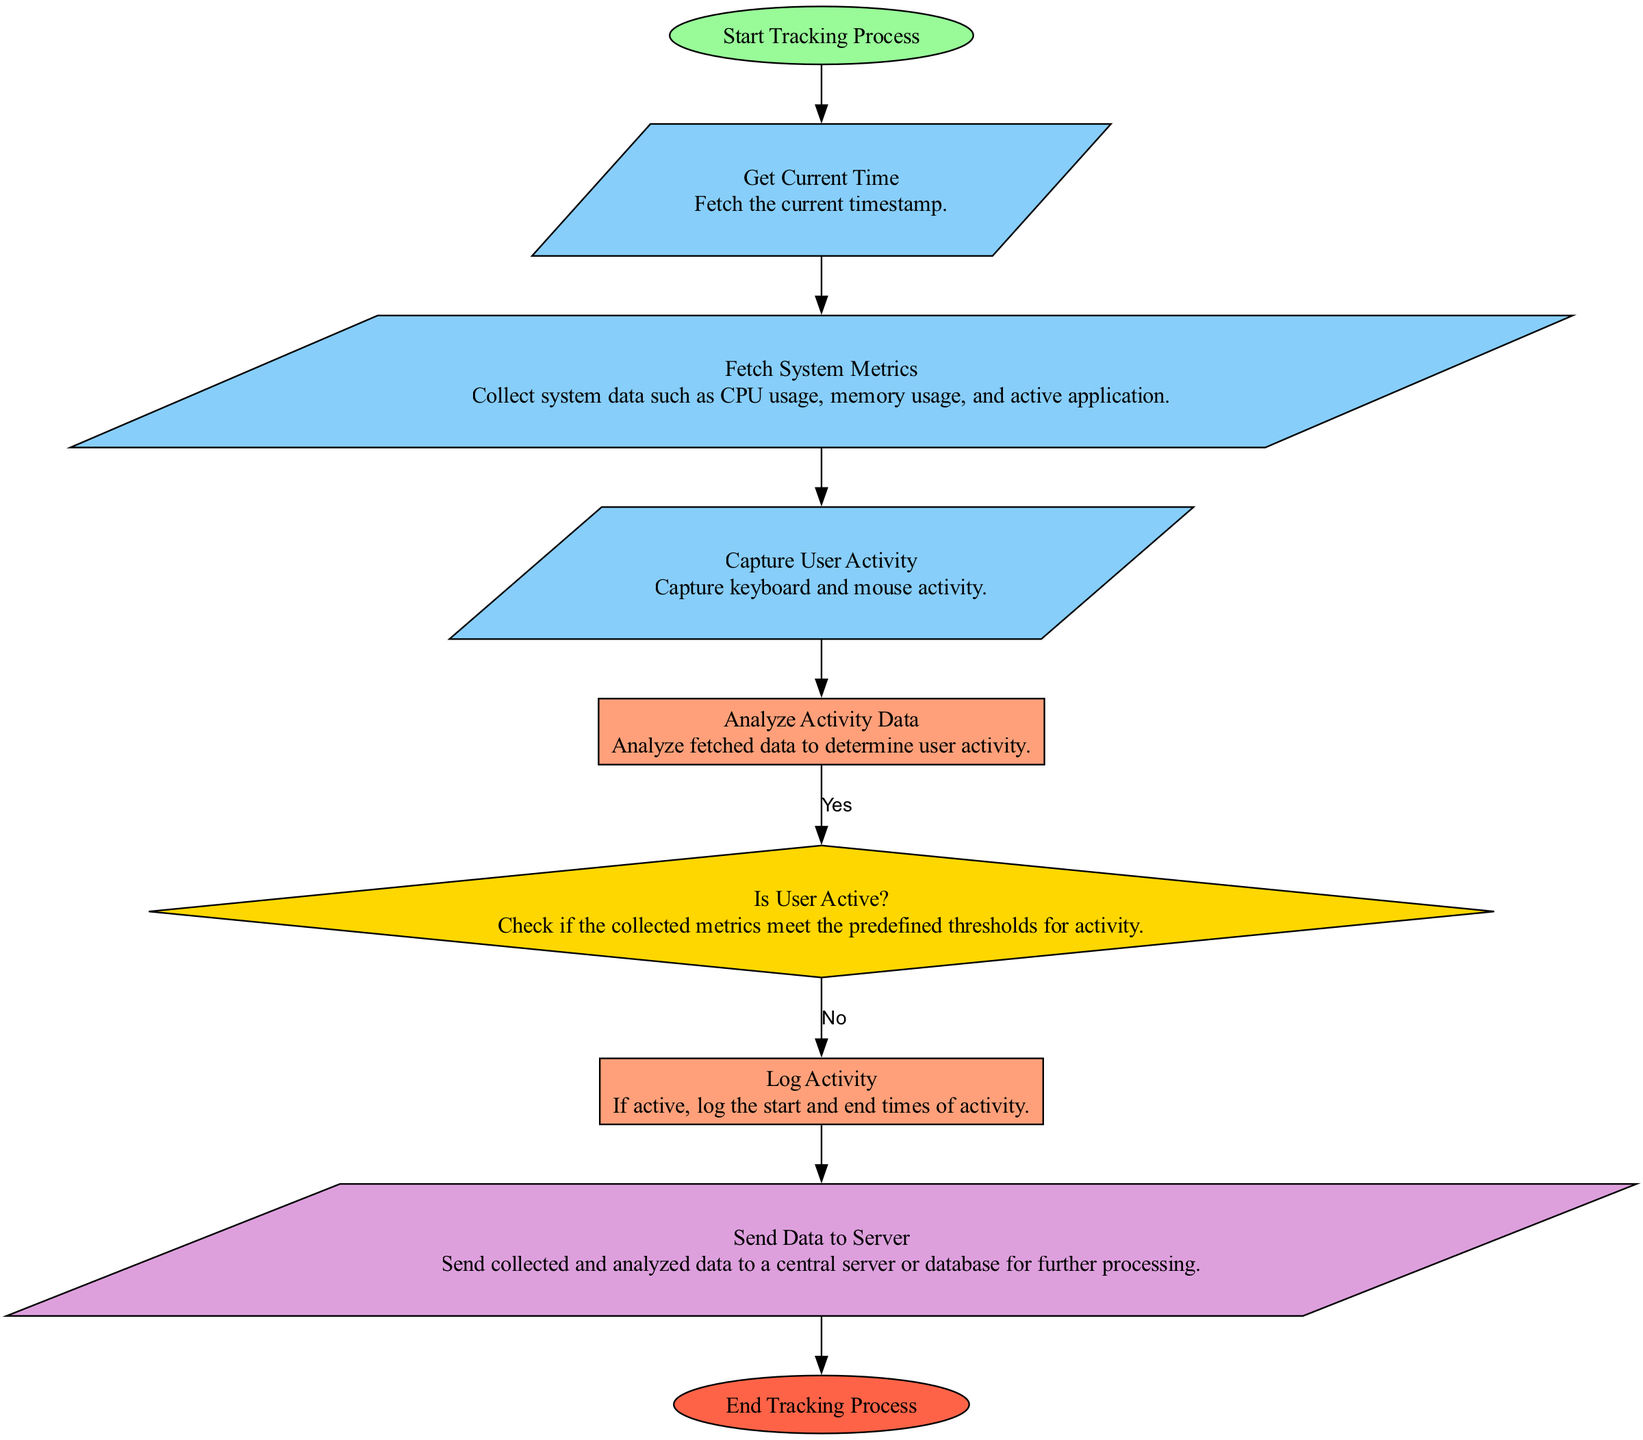What's the starting point of the process? The flowchart begins with the node labeled "Start Tracking Process". This indicates where the entire tracking process initiates.
Answer: Start Tracking Process How many inputs are there in the diagram? By analyzing the nodes in the flowchart, we find three input nodes: "Get Current Time", "Fetch System Metrics", and "Capture User Activity". Therefore, there are three input nodes.
Answer: 3 What is the first action taken after getting the current time? Following the node "Get Current Time", the next node is "Fetch System Metrics". This means fetching the system data is the immediate next action.
Answer: Fetch System Metrics Is there a decision point in the process? Yes, there is a decision node labeled "Is User Active?" which evaluates the user activity based on defined thresholds. This indicates a decision point in the flowchart.
Answer: Yes What happens if the user is active? If the decision node "Is User Active?" evaluates to true (Yes), the next action is to "Log Activity" where user activity details will be recorded.
Answer: Log Activity How many nodes are there in total? The flowchart contains a total of nine nodes, counting all start, input, process, decision, output, and end types present in the diagram.
Answer: 9 What does the final action of the process involve? The final action in the flowchart, after the user activity is logged, is represented by the node "End Tracking Process", which signifies the completion of tracking.
Answer: End Tracking Process What type of node follows the decision point in the scenario where the user is active? If the decision evaluates to Yes (indicating the user is active), the following node is "Log Activity", which is a process node responsible for recording activity.
Answer: Log Activity Where does the collected data go after analysis? After analyzing the activity data and concluding the user is active, the next step involves sending the collected and analyzed data to a server or database as outlined in the "Send Data to Server" node.
Answer: Send Data to Server 